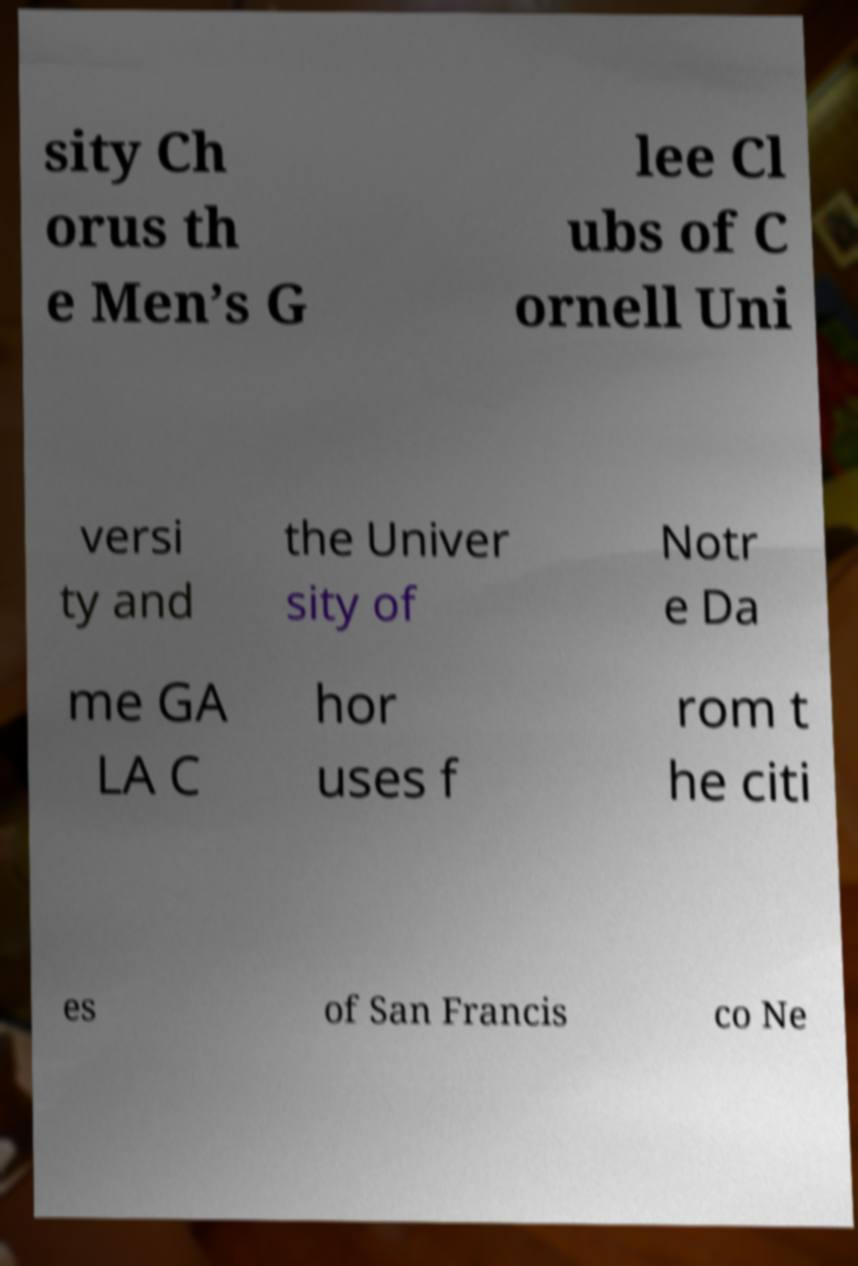Can you accurately transcribe the text from the provided image for me? sity Ch orus th e Men’s G lee Cl ubs of C ornell Uni versi ty and the Univer sity of Notr e Da me GA LA C hor uses f rom t he citi es of San Francis co Ne 